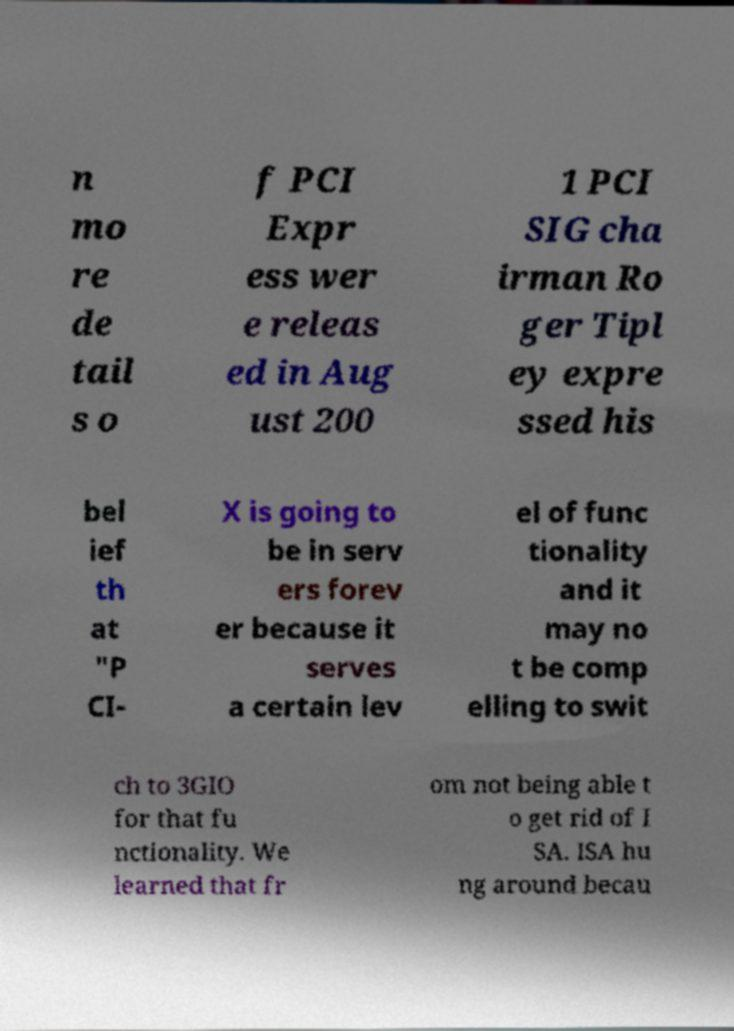What messages or text are displayed in this image? I need them in a readable, typed format. n mo re de tail s o f PCI Expr ess wer e releas ed in Aug ust 200 1 PCI SIG cha irman Ro ger Tipl ey expre ssed his bel ief th at "P CI- X is going to be in serv ers forev er because it serves a certain lev el of func tionality and it may no t be comp elling to swit ch to 3GIO for that fu nctionality. We learned that fr om not being able t o get rid of I SA. ISA hu ng around becau 